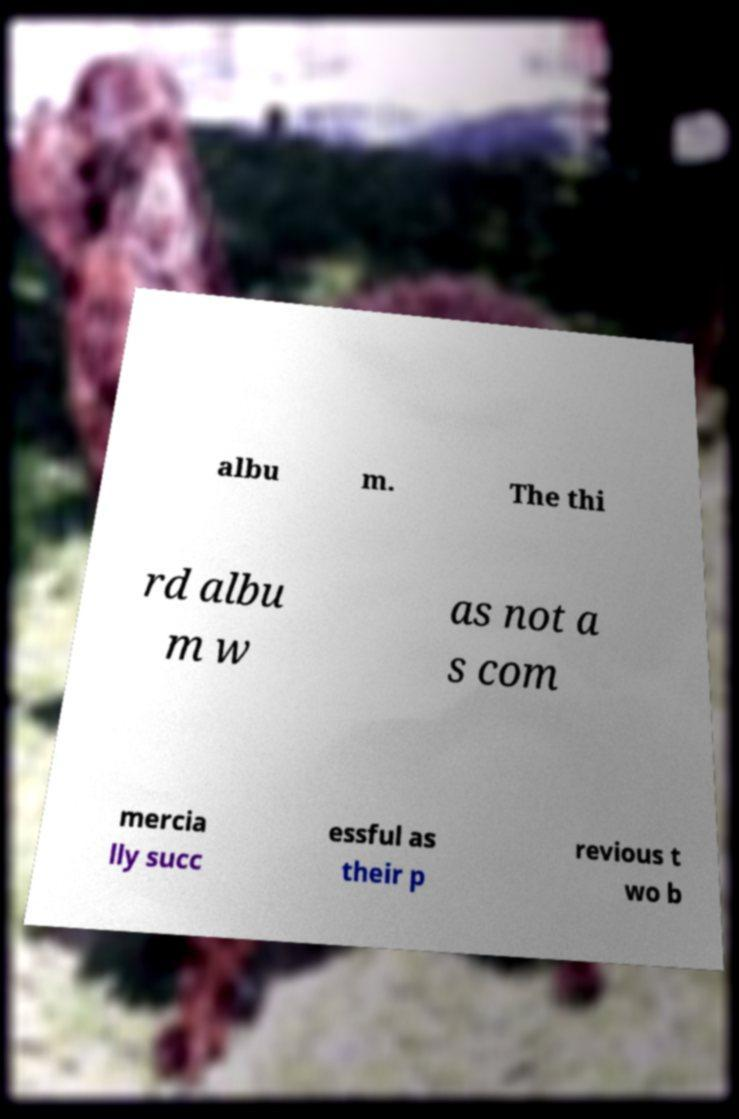There's text embedded in this image that I need extracted. Can you transcribe it verbatim? albu m. The thi rd albu m w as not a s com mercia lly succ essful as their p revious t wo b 